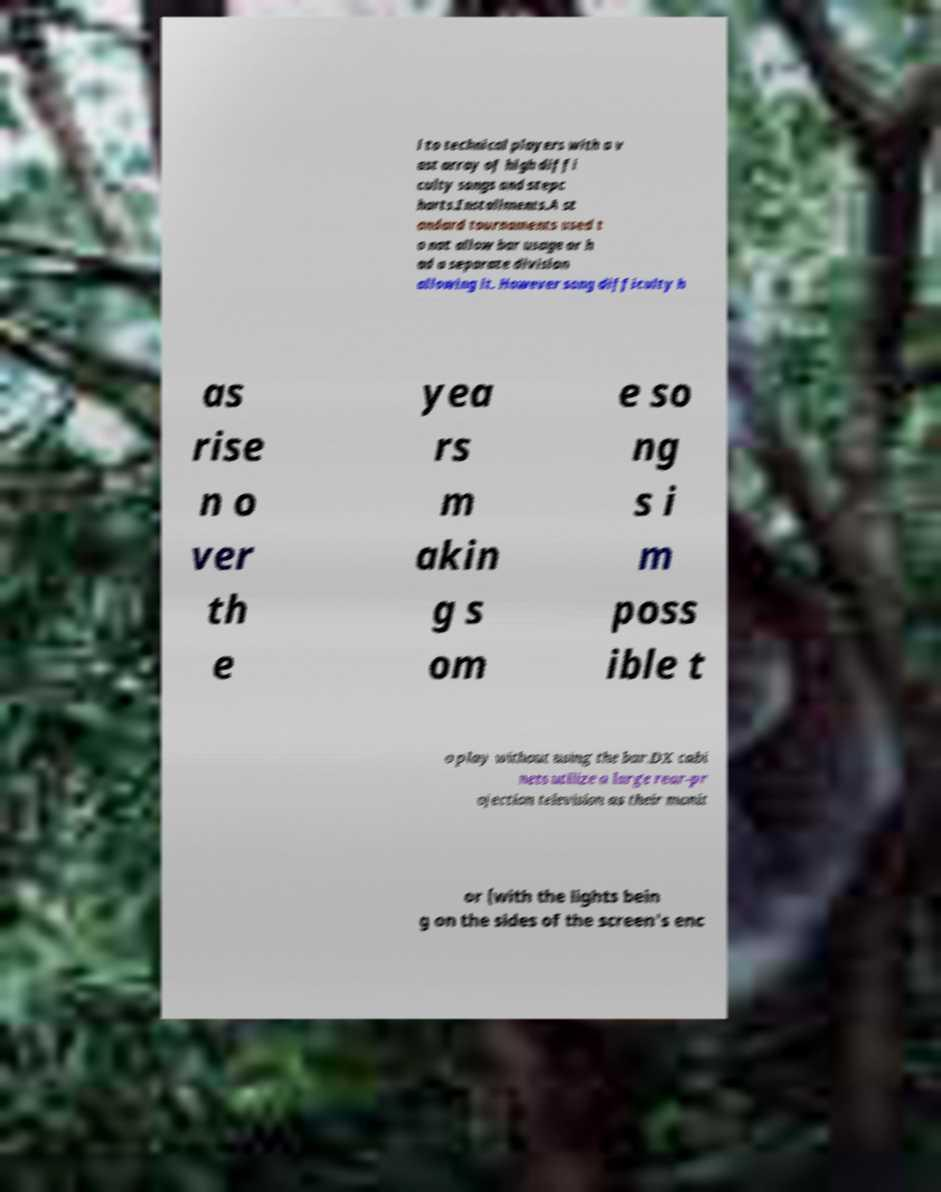Please read and relay the text visible in this image. What does it say? l to technical players with a v ast array of high diffi culty songs and stepc harts.Installments.A st andard tournaments used t o not allow bar usage or h ad a separate division allowing it. However song difficulty h as rise n o ver th e yea rs m akin g s om e so ng s i m poss ible t o play without using the bar.DX cabi nets utilize a large rear-pr ojection television as their monit or (with the lights bein g on the sides of the screen's enc 